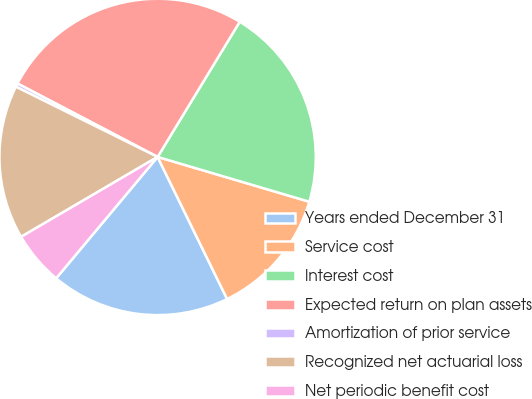<chart> <loc_0><loc_0><loc_500><loc_500><pie_chart><fcel>Years ended December 31<fcel>Service cost<fcel>Interest cost<fcel>Expected return on plan assets<fcel>Amortization of prior service<fcel>Recognized net actuarial loss<fcel>Net periodic benefit cost<nl><fcel>18.32%<fcel>13.19%<fcel>20.88%<fcel>26.01%<fcel>0.36%<fcel>15.75%<fcel>5.49%<nl></chart> 